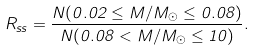<formula> <loc_0><loc_0><loc_500><loc_500>R _ { s s } = \frac { N ( 0 . 0 2 \leq M / M _ { \odot } \leq 0 . 0 8 ) } { N ( 0 . 0 8 < M / M _ { \odot } \leq 1 0 ) } .</formula> 